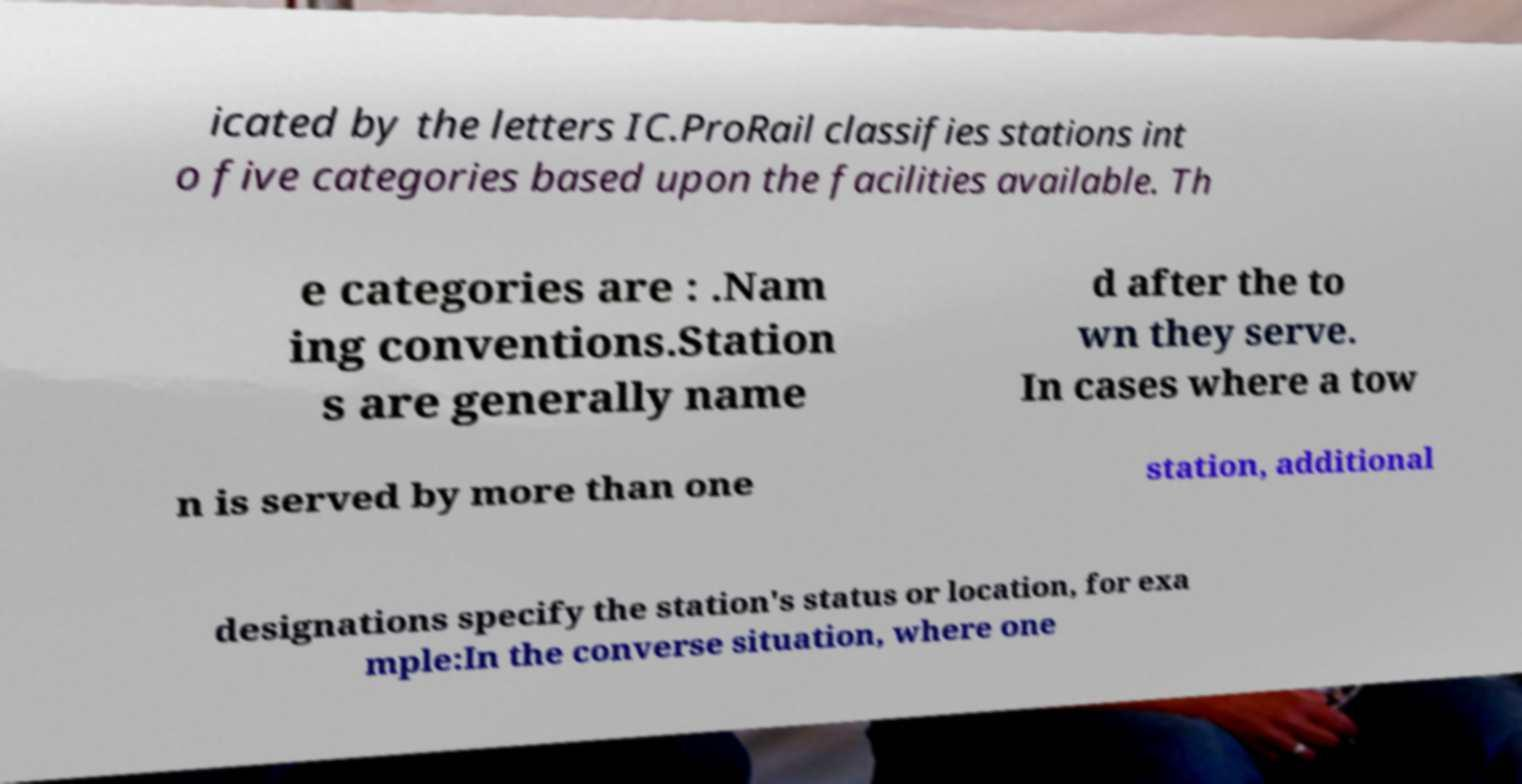For documentation purposes, I need the text within this image transcribed. Could you provide that? icated by the letters IC.ProRail classifies stations int o five categories based upon the facilities available. Th e categories are : .Nam ing conventions.Station s are generally name d after the to wn they serve. In cases where a tow n is served by more than one station, additional designations specify the station's status or location, for exa mple:In the converse situation, where one 